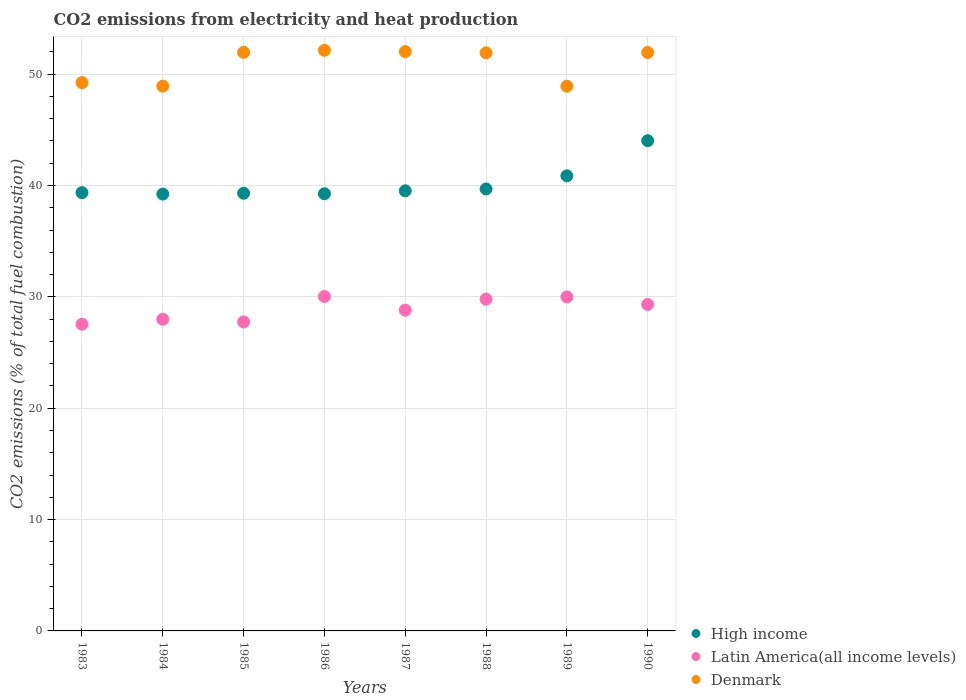Is the number of dotlines equal to the number of legend labels?
Offer a very short reply. Yes. What is the amount of CO2 emitted in High income in 1984?
Offer a very short reply. 39.23. Across all years, what is the maximum amount of CO2 emitted in High income?
Your answer should be very brief. 44.02. Across all years, what is the minimum amount of CO2 emitted in Denmark?
Offer a very short reply. 48.92. In which year was the amount of CO2 emitted in Denmark maximum?
Keep it short and to the point. 1986. In which year was the amount of CO2 emitted in Latin America(all income levels) minimum?
Provide a succinct answer. 1983. What is the total amount of CO2 emitted in Latin America(all income levels) in the graph?
Provide a short and direct response. 231.22. What is the difference between the amount of CO2 emitted in Latin America(all income levels) in 1986 and that in 1988?
Your answer should be very brief. 0.24. What is the difference between the amount of CO2 emitted in Latin America(all income levels) in 1984 and the amount of CO2 emitted in Denmark in 1987?
Ensure brevity in your answer.  -24.03. What is the average amount of CO2 emitted in High income per year?
Offer a terse response. 40.16. In the year 1987, what is the difference between the amount of CO2 emitted in Latin America(all income levels) and amount of CO2 emitted in High income?
Provide a succinct answer. -10.72. In how many years, is the amount of CO2 emitted in Latin America(all income levels) greater than 48 %?
Give a very brief answer. 0. What is the ratio of the amount of CO2 emitted in Denmark in 1983 to that in 1988?
Give a very brief answer. 0.95. Is the amount of CO2 emitted in Denmark in 1988 less than that in 1989?
Make the answer very short. No. Is the difference between the amount of CO2 emitted in Latin America(all income levels) in 1984 and 1990 greater than the difference between the amount of CO2 emitted in High income in 1984 and 1990?
Your answer should be very brief. Yes. What is the difference between the highest and the second highest amount of CO2 emitted in Denmark?
Keep it short and to the point. 0.12. What is the difference between the highest and the lowest amount of CO2 emitted in High income?
Your response must be concise. 4.79. Is the sum of the amount of CO2 emitted in High income in 1985 and 1988 greater than the maximum amount of CO2 emitted in Latin America(all income levels) across all years?
Provide a short and direct response. Yes. Does the amount of CO2 emitted in Denmark monotonically increase over the years?
Offer a terse response. No. Is the amount of CO2 emitted in Latin America(all income levels) strictly greater than the amount of CO2 emitted in Denmark over the years?
Keep it short and to the point. No. How many legend labels are there?
Provide a succinct answer. 3. How are the legend labels stacked?
Offer a terse response. Vertical. What is the title of the graph?
Provide a succinct answer. CO2 emissions from electricity and heat production. What is the label or title of the X-axis?
Your response must be concise. Years. What is the label or title of the Y-axis?
Give a very brief answer. CO2 emissions (% of total fuel combustion). What is the CO2 emissions (% of total fuel combustion) of High income in 1983?
Your answer should be compact. 39.36. What is the CO2 emissions (% of total fuel combustion) in Latin America(all income levels) in 1983?
Keep it short and to the point. 27.54. What is the CO2 emissions (% of total fuel combustion) in Denmark in 1983?
Give a very brief answer. 49.24. What is the CO2 emissions (% of total fuel combustion) in High income in 1984?
Ensure brevity in your answer.  39.23. What is the CO2 emissions (% of total fuel combustion) of Latin America(all income levels) in 1984?
Keep it short and to the point. 27.99. What is the CO2 emissions (% of total fuel combustion) in Denmark in 1984?
Ensure brevity in your answer.  48.92. What is the CO2 emissions (% of total fuel combustion) of High income in 1985?
Provide a short and direct response. 39.31. What is the CO2 emissions (% of total fuel combustion) in Latin America(all income levels) in 1985?
Your answer should be very brief. 27.75. What is the CO2 emissions (% of total fuel combustion) of Denmark in 1985?
Your response must be concise. 51.96. What is the CO2 emissions (% of total fuel combustion) of High income in 1986?
Offer a very short reply. 39.26. What is the CO2 emissions (% of total fuel combustion) in Latin America(all income levels) in 1986?
Keep it short and to the point. 30.03. What is the CO2 emissions (% of total fuel combustion) of Denmark in 1986?
Your answer should be compact. 52.14. What is the CO2 emissions (% of total fuel combustion) of High income in 1987?
Your answer should be very brief. 39.52. What is the CO2 emissions (% of total fuel combustion) in Latin America(all income levels) in 1987?
Offer a very short reply. 28.8. What is the CO2 emissions (% of total fuel combustion) of Denmark in 1987?
Keep it short and to the point. 52.02. What is the CO2 emissions (% of total fuel combustion) of High income in 1988?
Ensure brevity in your answer.  39.69. What is the CO2 emissions (% of total fuel combustion) of Latin America(all income levels) in 1988?
Ensure brevity in your answer.  29.79. What is the CO2 emissions (% of total fuel combustion) in Denmark in 1988?
Offer a terse response. 51.92. What is the CO2 emissions (% of total fuel combustion) in High income in 1989?
Make the answer very short. 40.87. What is the CO2 emissions (% of total fuel combustion) in Latin America(all income levels) in 1989?
Offer a very short reply. 29.99. What is the CO2 emissions (% of total fuel combustion) of Denmark in 1989?
Offer a very short reply. 48.92. What is the CO2 emissions (% of total fuel combustion) in High income in 1990?
Offer a terse response. 44.02. What is the CO2 emissions (% of total fuel combustion) of Latin America(all income levels) in 1990?
Ensure brevity in your answer.  29.32. What is the CO2 emissions (% of total fuel combustion) in Denmark in 1990?
Ensure brevity in your answer.  51.95. Across all years, what is the maximum CO2 emissions (% of total fuel combustion) in High income?
Your answer should be compact. 44.02. Across all years, what is the maximum CO2 emissions (% of total fuel combustion) of Latin America(all income levels)?
Your answer should be very brief. 30.03. Across all years, what is the maximum CO2 emissions (% of total fuel combustion) of Denmark?
Your answer should be compact. 52.14. Across all years, what is the minimum CO2 emissions (% of total fuel combustion) of High income?
Provide a succinct answer. 39.23. Across all years, what is the minimum CO2 emissions (% of total fuel combustion) in Latin America(all income levels)?
Make the answer very short. 27.54. Across all years, what is the minimum CO2 emissions (% of total fuel combustion) in Denmark?
Offer a terse response. 48.92. What is the total CO2 emissions (% of total fuel combustion) of High income in the graph?
Offer a very short reply. 321.25. What is the total CO2 emissions (% of total fuel combustion) in Latin America(all income levels) in the graph?
Provide a succinct answer. 231.22. What is the total CO2 emissions (% of total fuel combustion) in Denmark in the graph?
Offer a very short reply. 407.07. What is the difference between the CO2 emissions (% of total fuel combustion) of High income in 1983 and that in 1984?
Make the answer very short. 0.13. What is the difference between the CO2 emissions (% of total fuel combustion) of Latin America(all income levels) in 1983 and that in 1984?
Ensure brevity in your answer.  -0.45. What is the difference between the CO2 emissions (% of total fuel combustion) of Denmark in 1983 and that in 1984?
Make the answer very short. 0.32. What is the difference between the CO2 emissions (% of total fuel combustion) in High income in 1983 and that in 1985?
Offer a terse response. 0.05. What is the difference between the CO2 emissions (% of total fuel combustion) of Latin America(all income levels) in 1983 and that in 1985?
Give a very brief answer. -0.21. What is the difference between the CO2 emissions (% of total fuel combustion) in Denmark in 1983 and that in 1985?
Ensure brevity in your answer.  -2.72. What is the difference between the CO2 emissions (% of total fuel combustion) of High income in 1983 and that in 1986?
Your answer should be compact. 0.1. What is the difference between the CO2 emissions (% of total fuel combustion) of Latin America(all income levels) in 1983 and that in 1986?
Offer a very short reply. -2.49. What is the difference between the CO2 emissions (% of total fuel combustion) in Denmark in 1983 and that in 1986?
Your response must be concise. -2.9. What is the difference between the CO2 emissions (% of total fuel combustion) of High income in 1983 and that in 1987?
Make the answer very short. -0.17. What is the difference between the CO2 emissions (% of total fuel combustion) in Latin America(all income levels) in 1983 and that in 1987?
Provide a short and direct response. -1.26. What is the difference between the CO2 emissions (% of total fuel combustion) of Denmark in 1983 and that in 1987?
Provide a succinct answer. -2.78. What is the difference between the CO2 emissions (% of total fuel combustion) in High income in 1983 and that in 1988?
Ensure brevity in your answer.  -0.33. What is the difference between the CO2 emissions (% of total fuel combustion) of Latin America(all income levels) in 1983 and that in 1988?
Your response must be concise. -2.25. What is the difference between the CO2 emissions (% of total fuel combustion) in Denmark in 1983 and that in 1988?
Your answer should be compact. -2.68. What is the difference between the CO2 emissions (% of total fuel combustion) of High income in 1983 and that in 1989?
Provide a short and direct response. -1.51. What is the difference between the CO2 emissions (% of total fuel combustion) in Latin America(all income levels) in 1983 and that in 1989?
Your response must be concise. -2.45. What is the difference between the CO2 emissions (% of total fuel combustion) of Denmark in 1983 and that in 1989?
Ensure brevity in your answer.  0.32. What is the difference between the CO2 emissions (% of total fuel combustion) of High income in 1983 and that in 1990?
Your response must be concise. -4.67. What is the difference between the CO2 emissions (% of total fuel combustion) in Latin America(all income levels) in 1983 and that in 1990?
Your response must be concise. -1.78. What is the difference between the CO2 emissions (% of total fuel combustion) of Denmark in 1983 and that in 1990?
Make the answer very short. -2.71. What is the difference between the CO2 emissions (% of total fuel combustion) in High income in 1984 and that in 1985?
Provide a succinct answer. -0.08. What is the difference between the CO2 emissions (% of total fuel combustion) of Latin America(all income levels) in 1984 and that in 1985?
Your answer should be compact. 0.24. What is the difference between the CO2 emissions (% of total fuel combustion) in Denmark in 1984 and that in 1985?
Offer a terse response. -3.04. What is the difference between the CO2 emissions (% of total fuel combustion) of High income in 1984 and that in 1986?
Make the answer very short. -0.03. What is the difference between the CO2 emissions (% of total fuel combustion) of Latin America(all income levels) in 1984 and that in 1986?
Give a very brief answer. -2.04. What is the difference between the CO2 emissions (% of total fuel combustion) in Denmark in 1984 and that in 1986?
Give a very brief answer. -3.22. What is the difference between the CO2 emissions (% of total fuel combustion) of High income in 1984 and that in 1987?
Your answer should be very brief. -0.29. What is the difference between the CO2 emissions (% of total fuel combustion) in Latin America(all income levels) in 1984 and that in 1987?
Offer a terse response. -0.81. What is the difference between the CO2 emissions (% of total fuel combustion) in Denmark in 1984 and that in 1987?
Offer a terse response. -3.1. What is the difference between the CO2 emissions (% of total fuel combustion) in High income in 1984 and that in 1988?
Your response must be concise. -0.46. What is the difference between the CO2 emissions (% of total fuel combustion) in Latin America(all income levels) in 1984 and that in 1988?
Make the answer very short. -1.8. What is the difference between the CO2 emissions (% of total fuel combustion) in Denmark in 1984 and that in 1988?
Your answer should be compact. -3. What is the difference between the CO2 emissions (% of total fuel combustion) in High income in 1984 and that in 1989?
Offer a very short reply. -1.64. What is the difference between the CO2 emissions (% of total fuel combustion) of Latin America(all income levels) in 1984 and that in 1989?
Ensure brevity in your answer.  -2. What is the difference between the CO2 emissions (% of total fuel combustion) in Denmark in 1984 and that in 1989?
Offer a terse response. 0.01. What is the difference between the CO2 emissions (% of total fuel combustion) of High income in 1984 and that in 1990?
Your response must be concise. -4.79. What is the difference between the CO2 emissions (% of total fuel combustion) of Latin America(all income levels) in 1984 and that in 1990?
Offer a terse response. -1.33. What is the difference between the CO2 emissions (% of total fuel combustion) in Denmark in 1984 and that in 1990?
Your answer should be very brief. -3.02. What is the difference between the CO2 emissions (% of total fuel combustion) of High income in 1985 and that in 1986?
Your answer should be very brief. 0.05. What is the difference between the CO2 emissions (% of total fuel combustion) in Latin America(all income levels) in 1985 and that in 1986?
Give a very brief answer. -2.29. What is the difference between the CO2 emissions (% of total fuel combustion) of Denmark in 1985 and that in 1986?
Ensure brevity in your answer.  -0.19. What is the difference between the CO2 emissions (% of total fuel combustion) in High income in 1985 and that in 1987?
Provide a short and direct response. -0.22. What is the difference between the CO2 emissions (% of total fuel combustion) of Latin America(all income levels) in 1985 and that in 1987?
Ensure brevity in your answer.  -1.05. What is the difference between the CO2 emissions (% of total fuel combustion) in Denmark in 1985 and that in 1987?
Make the answer very short. -0.07. What is the difference between the CO2 emissions (% of total fuel combustion) in High income in 1985 and that in 1988?
Your answer should be very brief. -0.38. What is the difference between the CO2 emissions (% of total fuel combustion) of Latin America(all income levels) in 1985 and that in 1988?
Offer a very short reply. -2.05. What is the difference between the CO2 emissions (% of total fuel combustion) of Denmark in 1985 and that in 1988?
Keep it short and to the point. 0.04. What is the difference between the CO2 emissions (% of total fuel combustion) in High income in 1985 and that in 1989?
Make the answer very short. -1.56. What is the difference between the CO2 emissions (% of total fuel combustion) in Latin America(all income levels) in 1985 and that in 1989?
Give a very brief answer. -2.24. What is the difference between the CO2 emissions (% of total fuel combustion) of Denmark in 1985 and that in 1989?
Your answer should be very brief. 3.04. What is the difference between the CO2 emissions (% of total fuel combustion) in High income in 1985 and that in 1990?
Provide a short and direct response. -4.72. What is the difference between the CO2 emissions (% of total fuel combustion) of Latin America(all income levels) in 1985 and that in 1990?
Give a very brief answer. -1.57. What is the difference between the CO2 emissions (% of total fuel combustion) of Denmark in 1985 and that in 1990?
Make the answer very short. 0.01. What is the difference between the CO2 emissions (% of total fuel combustion) in High income in 1986 and that in 1987?
Provide a short and direct response. -0.27. What is the difference between the CO2 emissions (% of total fuel combustion) of Latin America(all income levels) in 1986 and that in 1987?
Provide a succinct answer. 1.23. What is the difference between the CO2 emissions (% of total fuel combustion) of Denmark in 1986 and that in 1987?
Your response must be concise. 0.12. What is the difference between the CO2 emissions (% of total fuel combustion) of High income in 1986 and that in 1988?
Your answer should be compact. -0.43. What is the difference between the CO2 emissions (% of total fuel combustion) of Latin America(all income levels) in 1986 and that in 1988?
Your answer should be very brief. 0.24. What is the difference between the CO2 emissions (% of total fuel combustion) in Denmark in 1986 and that in 1988?
Provide a short and direct response. 0.23. What is the difference between the CO2 emissions (% of total fuel combustion) in High income in 1986 and that in 1989?
Make the answer very short. -1.61. What is the difference between the CO2 emissions (% of total fuel combustion) in Latin America(all income levels) in 1986 and that in 1989?
Your answer should be very brief. 0.04. What is the difference between the CO2 emissions (% of total fuel combustion) in Denmark in 1986 and that in 1989?
Give a very brief answer. 3.23. What is the difference between the CO2 emissions (% of total fuel combustion) in High income in 1986 and that in 1990?
Your response must be concise. -4.77. What is the difference between the CO2 emissions (% of total fuel combustion) in Latin America(all income levels) in 1986 and that in 1990?
Give a very brief answer. 0.72. What is the difference between the CO2 emissions (% of total fuel combustion) in Denmark in 1986 and that in 1990?
Your answer should be compact. 0.2. What is the difference between the CO2 emissions (% of total fuel combustion) in High income in 1987 and that in 1988?
Provide a short and direct response. -0.16. What is the difference between the CO2 emissions (% of total fuel combustion) of Latin America(all income levels) in 1987 and that in 1988?
Make the answer very short. -0.99. What is the difference between the CO2 emissions (% of total fuel combustion) in Denmark in 1987 and that in 1988?
Make the answer very short. 0.11. What is the difference between the CO2 emissions (% of total fuel combustion) of High income in 1987 and that in 1989?
Provide a short and direct response. -1.34. What is the difference between the CO2 emissions (% of total fuel combustion) of Latin America(all income levels) in 1987 and that in 1989?
Ensure brevity in your answer.  -1.19. What is the difference between the CO2 emissions (% of total fuel combustion) in Denmark in 1987 and that in 1989?
Offer a terse response. 3.11. What is the difference between the CO2 emissions (% of total fuel combustion) in High income in 1987 and that in 1990?
Provide a short and direct response. -4.5. What is the difference between the CO2 emissions (% of total fuel combustion) in Latin America(all income levels) in 1987 and that in 1990?
Give a very brief answer. -0.51. What is the difference between the CO2 emissions (% of total fuel combustion) in Denmark in 1987 and that in 1990?
Provide a short and direct response. 0.08. What is the difference between the CO2 emissions (% of total fuel combustion) in High income in 1988 and that in 1989?
Provide a succinct answer. -1.18. What is the difference between the CO2 emissions (% of total fuel combustion) of Latin America(all income levels) in 1988 and that in 1989?
Your answer should be very brief. -0.2. What is the difference between the CO2 emissions (% of total fuel combustion) of Denmark in 1988 and that in 1989?
Your answer should be compact. 3. What is the difference between the CO2 emissions (% of total fuel combustion) in High income in 1988 and that in 1990?
Make the answer very short. -4.34. What is the difference between the CO2 emissions (% of total fuel combustion) in Latin America(all income levels) in 1988 and that in 1990?
Your answer should be very brief. 0.48. What is the difference between the CO2 emissions (% of total fuel combustion) in Denmark in 1988 and that in 1990?
Your answer should be very brief. -0.03. What is the difference between the CO2 emissions (% of total fuel combustion) in High income in 1989 and that in 1990?
Make the answer very short. -3.16. What is the difference between the CO2 emissions (% of total fuel combustion) in Latin America(all income levels) in 1989 and that in 1990?
Offer a very short reply. 0.67. What is the difference between the CO2 emissions (% of total fuel combustion) of Denmark in 1989 and that in 1990?
Give a very brief answer. -3.03. What is the difference between the CO2 emissions (% of total fuel combustion) in High income in 1983 and the CO2 emissions (% of total fuel combustion) in Latin America(all income levels) in 1984?
Provide a succinct answer. 11.37. What is the difference between the CO2 emissions (% of total fuel combustion) in High income in 1983 and the CO2 emissions (% of total fuel combustion) in Denmark in 1984?
Your answer should be compact. -9.56. What is the difference between the CO2 emissions (% of total fuel combustion) in Latin America(all income levels) in 1983 and the CO2 emissions (% of total fuel combustion) in Denmark in 1984?
Your answer should be compact. -21.38. What is the difference between the CO2 emissions (% of total fuel combustion) of High income in 1983 and the CO2 emissions (% of total fuel combustion) of Latin America(all income levels) in 1985?
Offer a terse response. 11.61. What is the difference between the CO2 emissions (% of total fuel combustion) of High income in 1983 and the CO2 emissions (% of total fuel combustion) of Denmark in 1985?
Your response must be concise. -12.6. What is the difference between the CO2 emissions (% of total fuel combustion) of Latin America(all income levels) in 1983 and the CO2 emissions (% of total fuel combustion) of Denmark in 1985?
Provide a succinct answer. -24.42. What is the difference between the CO2 emissions (% of total fuel combustion) in High income in 1983 and the CO2 emissions (% of total fuel combustion) in Latin America(all income levels) in 1986?
Offer a terse response. 9.32. What is the difference between the CO2 emissions (% of total fuel combustion) in High income in 1983 and the CO2 emissions (% of total fuel combustion) in Denmark in 1986?
Provide a succinct answer. -12.79. What is the difference between the CO2 emissions (% of total fuel combustion) of Latin America(all income levels) in 1983 and the CO2 emissions (% of total fuel combustion) of Denmark in 1986?
Ensure brevity in your answer.  -24.6. What is the difference between the CO2 emissions (% of total fuel combustion) in High income in 1983 and the CO2 emissions (% of total fuel combustion) in Latin America(all income levels) in 1987?
Offer a very short reply. 10.55. What is the difference between the CO2 emissions (% of total fuel combustion) in High income in 1983 and the CO2 emissions (% of total fuel combustion) in Denmark in 1987?
Provide a short and direct response. -12.67. What is the difference between the CO2 emissions (% of total fuel combustion) of Latin America(all income levels) in 1983 and the CO2 emissions (% of total fuel combustion) of Denmark in 1987?
Make the answer very short. -24.48. What is the difference between the CO2 emissions (% of total fuel combustion) of High income in 1983 and the CO2 emissions (% of total fuel combustion) of Latin America(all income levels) in 1988?
Offer a very short reply. 9.56. What is the difference between the CO2 emissions (% of total fuel combustion) of High income in 1983 and the CO2 emissions (% of total fuel combustion) of Denmark in 1988?
Keep it short and to the point. -12.56. What is the difference between the CO2 emissions (% of total fuel combustion) in Latin America(all income levels) in 1983 and the CO2 emissions (% of total fuel combustion) in Denmark in 1988?
Offer a terse response. -24.38. What is the difference between the CO2 emissions (% of total fuel combustion) in High income in 1983 and the CO2 emissions (% of total fuel combustion) in Latin America(all income levels) in 1989?
Offer a terse response. 9.37. What is the difference between the CO2 emissions (% of total fuel combustion) of High income in 1983 and the CO2 emissions (% of total fuel combustion) of Denmark in 1989?
Make the answer very short. -9.56. What is the difference between the CO2 emissions (% of total fuel combustion) in Latin America(all income levels) in 1983 and the CO2 emissions (% of total fuel combustion) in Denmark in 1989?
Offer a very short reply. -21.38. What is the difference between the CO2 emissions (% of total fuel combustion) in High income in 1983 and the CO2 emissions (% of total fuel combustion) in Latin America(all income levels) in 1990?
Your response must be concise. 10.04. What is the difference between the CO2 emissions (% of total fuel combustion) in High income in 1983 and the CO2 emissions (% of total fuel combustion) in Denmark in 1990?
Provide a succinct answer. -12.59. What is the difference between the CO2 emissions (% of total fuel combustion) in Latin America(all income levels) in 1983 and the CO2 emissions (% of total fuel combustion) in Denmark in 1990?
Provide a succinct answer. -24.41. What is the difference between the CO2 emissions (% of total fuel combustion) in High income in 1984 and the CO2 emissions (% of total fuel combustion) in Latin America(all income levels) in 1985?
Offer a very short reply. 11.48. What is the difference between the CO2 emissions (% of total fuel combustion) in High income in 1984 and the CO2 emissions (% of total fuel combustion) in Denmark in 1985?
Ensure brevity in your answer.  -12.73. What is the difference between the CO2 emissions (% of total fuel combustion) of Latin America(all income levels) in 1984 and the CO2 emissions (% of total fuel combustion) of Denmark in 1985?
Offer a very short reply. -23.97. What is the difference between the CO2 emissions (% of total fuel combustion) in High income in 1984 and the CO2 emissions (% of total fuel combustion) in Latin America(all income levels) in 1986?
Your answer should be very brief. 9.19. What is the difference between the CO2 emissions (% of total fuel combustion) of High income in 1984 and the CO2 emissions (% of total fuel combustion) of Denmark in 1986?
Ensure brevity in your answer.  -12.91. What is the difference between the CO2 emissions (% of total fuel combustion) in Latin America(all income levels) in 1984 and the CO2 emissions (% of total fuel combustion) in Denmark in 1986?
Offer a very short reply. -24.15. What is the difference between the CO2 emissions (% of total fuel combustion) of High income in 1984 and the CO2 emissions (% of total fuel combustion) of Latin America(all income levels) in 1987?
Ensure brevity in your answer.  10.43. What is the difference between the CO2 emissions (% of total fuel combustion) of High income in 1984 and the CO2 emissions (% of total fuel combustion) of Denmark in 1987?
Offer a terse response. -12.79. What is the difference between the CO2 emissions (% of total fuel combustion) of Latin America(all income levels) in 1984 and the CO2 emissions (% of total fuel combustion) of Denmark in 1987?
Give a very brief answer. -24.03. What is the difference between the CO2 emissions (% of total fuel combustion) of High income in 1984 and the CO2 emissions (% of total fuel combustion) of Latin America(all income levels) in 1988?
Your answer should be very brief. 9.44. What is the difference between the CO2 emissions (% of total fuel combustion) of High income in 1984 and the CO2 emissions (% of total fuel combustion) of Denmark in 1988?
Offer a very short reply. -12.69. What is the difference between the CO2 emissions (% of total fuel combustion) in Latin America(all income levels) in 1984 and the CO2 emissions (% of total fuel combustion) in Denmark in 1988?
Give a very brief answer. -23.93. What is the difference between the CO2 emissions (% of total fuel combustion) in High income in 1984 and the CO2 emissions (% of total fuel combustion) in Latin America(all income levels) in 1989?
Keep it short and to the point. 9.24. What is the difference between the CO2 emissions (% of total fuel combustion) in High income in 1984 and the CO2 emissions (% of total fuel combustion) in Denmark in 1989?
Keep it short and to the point. -9.69. What is the difference between the CO2 emissions (% of total fuel combustion) in Latin America(all income levels) in 1984 and the CO2 emissions (% of total fuel combustion) in Denmark in 1989?
Ensure brevity in your answer.  -20.93. What is the difference between the CO2 emissions (% of total fuel combustion) of High income in 1984 and the CO2 emissions (% of total fuel combustion) of Latin America(all income levels) in 1990?
Offer a very short reply. 9.91. What is the difference between the CO2 emissions (% of total fuel combustion) of High income in 1984 and the CO2 emissions (% of total fuel combustion) of Denmark in 1990?
Offer a terse response. -12.72. What is the difference between the CO2 emissions (% of total fuel combustion) in Latin America(all income levels) in 1984 and the CO2 emissions (% of total fuel combustion) in Denmark in 1990?
Offer a terse response. -23.96. What is the difference between the CO2 emissions (% of total fuel combustion) of High income in 1985 and the CO2 emissions (% of total fuel combustion) of Latin America(all income levels) in 1986?
Keep it short and to the point. 9.27. What is the difference between the CO2 emissions (% of total fuel combustion) of High income in 1985 and the CO2 emissions (% of total fuel combustion) of Denmark in 1986?
Offer a very short reply. -12.84. What is the difference between the CO2 emissions (% of total fuel combustion) in Latin America(all income levels) in 1985 and the CO2 emissions (% of total fuel combustion) in Denmark in 1986?
Offer a terse response. -24.39. What is the difference between the CO2 emissions (% of total fuel combustion) in High income in 1985 and the CO2 emissions (% of total fuel combustion) in Latin America(all income levels) in 1987?
Make the answer very short. 10.5. What is the difference between the CO2 emissions (% of total fuel combustion) in High income in 1985 and the CO2 emissions (% of total fuel combustion) in Denmark in 1987?
Give a very brief answer. -12.72. What is the difference between the CO2 emissions (% of total fuel combustion) in Latin America(all income levels) in 1985 and the CO2 emissions (% of total fuel combustion) in Denmark in 1987?
Give a very brief answer. -24.28. What is the difference between the CO2 emissions (% of total fuel combustion) of High income in 1985 and the CO2 emissions (% of total fuel combustion) of Latin America(all income levels) in 1988?
Your response must be concise. 9.51. What is the difference between the CO2 emissions (% of total fuel combustion) of High income in 1985 and the CO2 emissions (% of total fuel combustion) of Denmark in 1988?
Provide a succinct answer. -12.61. What is the difference between the CO2 emissions (% of total fuel combustion) in Latin America(all income levels) in 1985 and the CO2 emissions (% of total fuel combustion) in Denmark in 1988?
Offer a very short reply. -24.17. What is the difference between the CO2 emissions (% of total fuel combustion) in High income in 1985 and the CO2 emissions (% of total fuel combustion) in Latin America(all income levels) in 1989?
Your answer should be compact. 9.31. What is the difference between the CO2 emissions (% of total fuel combustion) in High income in 1985 and the CO2 emissions (% of total fuel combustion) in Denmark in 1989?
Provide a short and direct response. -9.61. What is the difference between the CO2 emissions (% of total fuel combustion) of Latin America(all income levels) in 1985 and the CO2 emissions (% of total fuel combustion) of Denmark in 1989?
Offer a very short reply. -21.17. What is the difference between the CO2 emissions (% of total fuel combustion) of High income in 1985 and the CO2 emissions (% of total fuel combustion) of Latin America(all income levels) in 1990?
Keep it short and to the point. 9.99. What is the difference between the CO2 emissions (% of total fuel combustion) of High income in 1985 and the CO2 emissions (% of total fuel combustion) of Denmark in 1990?
Offer a very short reply. -12.64. What is the difference between the CO2 emissions (% of total fuel combustion) in Latin America(all income levels) in 1985 and the CO2 emissions (% of total fuel combustion) in Denmark in 1990?
Your answer should be compact. -24.2. What is the difference between the CO2 emissions (% of total fuel combustion) of High income in 1986 and the CO2 emissions (% of total fuel combustion) of Latin America(all income levels) in 1987?
Your answer should be compact. 10.45. What is the difference between the CO2 emissions (% of total fuel combustion) in High income in 1986 and the CO2 emissions (% of total fuel combustion) in Denmark in 1987?
Ensure brevity in your answer.  -12.77. What is the difference between the CO2 emissions (% of total fuel combustion) of Latin America(all income levels) in 1986 and the CO2 emissions (% of total fuel combustion) of Denmark in 1987?
Make the answer very short. -21.99. What is the difference between the CO2 emissions (% of total fuel combustion) in High income in 1986 and the CO2 emissions (% of total fuel combustion) in Latin America(all income levels) in 1988?
Offer a very short reply. 9.46. What is the difference between the CO2 emissions (% of total fuel combustion) of High income in 1986 and the CO2 emissions (% of total fuel combustion) of Denmark in 1988?
Ensure brevity in your answer.  -12.66. What is the difference between the CO2 emissions (% of total fuel combustion) of Latin America(all income levels) in 1986 and the CO2 emissions (% of total fuel combustion) of Denmark in 1988?
Ensure brevity in your answer.  -21.88. What is the difference between the CO2 emissions (% of total fuel combustion) in High income in 1986 and the CO2 emissions (% of total fuel combustion) in Latin America(all income levels) in 1989?
Your answer should be compact. 9.27. What is the difference between the CO2 emissions (% of total fuel combustion) in High income in 1986 and the CO2 emissions (% of total fuel combustion) in Denmark in 1989?
Ensure brevity in your answer.  -9.66. What is the difference between the CO2 emissions (% of total fuel combustion) of Latin America(all income levels) in 1986 and the CO2 emissions (% of total fuel combustion) of Denmark in 1989?
Give a very brief answer. -18.88. What is the difference between the CO2 emissions (% of total fuel combustion) of High income in 1986 and the CO2 emissions (% of total fuel combustion) of Latin America(all income levels) in 1990?
Keep it short and to the point. 9.94. What is the difference between the CO2 emissions (% of total fuel combustion) of High income in 1986 and the CO2 emissions (% of total fuel combustion) of Denmark in 1990?
Provide a succinct answer. -12.69. What is the difference between the CO2 emissions (% of total fuel combustion) of Latin America(all income levels) in 1986 and the CO2 emissions (% of total fuel combustion) of Denmark in 1990?
Your answer should be compact. -21.91. What is the difference between the CO2 emissions (% of total fuel combustion) in High income in 1987 and the CO2 emissions (% of total fuel combustion) in Latin America(all income levels) in 1988?
Give a very brief answer. 9.73. What is the difference between the CO2 emissions (% of total fuel combustion) of High income in 1987 and the CO2 emissions (% of total fuel combustion) of Denmark in 1988?
Your answer should be very brief. -12.39. What is the difference between the CO2 emissions (% of total fuel combustion) in Latin America(all income levels) in 1987 and the CO2 emissions (% of total fuel combustion) in Denmark in 1988?
Offer a very short reply. -23.12. What is the difference between the CO2 emissions (% of total fuel combustion) in High income in 1987 and the CO2 emissions (% of total fuel combustion) in Latin America(all income levels) in 1989?
Offer a terse response. 9.53. What is the difference between the CO2 emissions (% of total fuel combustion) in High income in 1987 and the CO2 emissions (% of total fuel combustion) in Denmark in 1989?
Your answer should be very brief. -9.39. What is the difference between the CO2 emissions (% of total fuel combustion) in Latin America(all income levels) in 1987 and the CO2 emissions (% of total fuel combustion) in Denmark in 1989?
Ensure brevity in your answer.  -20.11. What is the difference between the CO2 emissions (% of total fuel combustion) of High income in 1987 and the CO2 emissions (% of total fuel combustion) of Latin America(all income levels) in 1990?
Your response must be concise. 10.21. What is the difference between the CO2 emissions (% of total fuel combustion) of High income in 1987 and the CO2 emissions (% of total fuel combustion) of Denmark in 1990?
Provide a succinct answer. -12.42. What is the difference between the CO2 emissions (% of total fuel combustion) of Latin America(all income levels) in 1987 and the CO2 emissions (% of total fuel combustion) of Denmark in 1990?
Keep it short and to the point. -23.14. What is the difference between the CO2 emissions (% of total fuel combustion) of High income in 1988 and the CO2 emissions (% of total fuel combustion) of Latin America(all income levels) in 1989?
Offer a very short reply. 9.7. What is the difference between the CO2 emissions (% of total fuel combustion) in High income in 1988 and the CO2 emissions (% of total fuel combustion) in Denmark in 1989?
Give a very brief answer. -9.23. What is the difference between the CO2 emissions (% of total fuel combustion) of Latin America(all income levels) in 1988 and the CO2 emissions (% of total fuel combustion) of Denmark in 1989?
Your answer should be compact. -19.12. What is the difference between the CO2 emissions (% of total fuel combustion) in High income in 1988 and the CO2 emissions (% of total fuel combustion) in Latin America(all income levels) in 1990?
Give a very brief answer. 10.37. What is the difference between the CO2 emissions (% of total fuel combustion) in High income in 1988 and the CO2 emissions (% of total fuel combustion) in Denmark in 1990?
Make the answer very short. -12.26. What is the difference between the CO2 emissions (% of total fuel combustion) in Latin America(all income levels) in 1988 and the CO2 emissions (% of total fuel combustion) in Denmark in 1990?
Your answer should be compact. -22.15. What is the difference between the CO2 emissions (% of total fuel combustion) of High income in 1989 and the CO2 emissions (% of total fuel combustion) of Latin America(all income levels) in 1990?
Provide a short and direct response. 11.55. What is the difference between the CO2 emissions (% of total fuel combustion) in High income in 1989 and the CO2 emissions (% of total fuel combustion) in Denmark in 1990?
Give a very brief answer. -11.08. What is the difference between the CO2 emissions (% of total fuel combustion) in Latin America(all income levels) in 1989 and the CO2 emissions (% of total fuel combustion) in Denmark in 1990?
Provide a short and direct response. -21.95. What is the average CO2 emissions (% of total fuel combustion) of High income per year?
Offer a very short reply. 40.16. What is the average CO2 emissions (% of total fuel combustion) in Latin America(all income levels) per year?
Keep it short and to the point. 28.9. What is the average CO2 emissions (% of total fuel combustion) of Denmark per year?
Your answer should be compact. 50.88. In the year 1983, what is the difference between the CO2 emissions (% of total fuel combustion) of High income and CO2 emissions (% of total fuel combustion) of Latin America(all income levels)?
Keep it short and to the point. 11.82. In the year 1983, what is the difference between the CO2 emissions (% of total fuel combustion) of High income and CO2 emissions (% of total fuel combustion) of Denmark?
Offer a very short reply. -9.88. In the year 1983, what is the difference between the CO2 emissions (% of total fuel combustion) in Latin America(all income levels) and CO2 emissions (% of total fuel combustion) in Denmark?
Make the answer very short. -21.7. In the year 1984, what is the difference between the CO2 emissions (% of total fuel combustion) in High income and CO2 emissions (% of total fuel combustion) in Latin America(all income levels)?
Offer a very short reply. 11.24. In the year 1984, what is the difference between the CO2 emissions (% of total fuel combustion) of High income and CO2 emissions (% of total fuel combustion) of Denmark?
Your response must be concise. -9.69. In the year 1984, what is the difference between the CO2 emissions (% of total fuel combustion) in Latin America(all income levels) and CO2 emissions (% of total fuel combustion) in Denmark?
Provide a succinct answer. -20.93. In the year 1985, what is the difference between the CO2 emissions (% of total fuel combustion) in High income and CO2 emissions (% of total fuel combustion) in Latin America(all income levels)?
Provide a succinct answer. 11.56. In the year 1985, what is the difference between the CO2 emissions (% of total fuel combustion) in High income and CO2 emissions (% of total fuel combustion) in Denmark?
Your response must be concise. -12.65. In the year 1985, what is the difference between the CO2 emissions (% of total fuel combustion) of Latin America(all income levels) and CO2 emissions (% of total fuel combustion) of Denmark?
Ensure brevity in your answer.  -24.21. In the year 1986, what is the difference between the CO2 emissions (% of total fuel combustion) of High income and CO2 emissions (% of total fuel combustion) of Latin America(all income levels)?
Keep it short and to the point. 9.22. In the year 1986, what is the difference between the CO2 emissions (% of total fuel combustion) of High income and CO2 emissions (% of total fuel combustion) of Denmark?
Ensure brevity in your answer.  -12.89. In the year 1986, what is the difference between the CO2 emissions (% of total fuel combustion) in Latin America(all income levels) and CO2 emissions (% of total fuel combustion) in Denmark?
Make the answer very short. -22.11. In the year 1987, what is the difference between the CO2 emissions (% of total fuel combustion) in High income and CO2 emissions (% of total fuel combustion) in Latin America(all income levels)?
Make the answer very short. 10.72. In the year 1987, what is the difference between the CO2 emissions (% of total fuel combustion) of High income and CO2 emissions (% of total fuel combustion) of Denmark?
Your answer should be very brief. -12.5. In the year 1987, what is the difference between the CO2 emissions (% of total fuel combustion) of Latin America(all income levels) and CO2 emissions (% of total fuel combustion) of Denmark?
Offer a terse response. -23.22. In the year 1988, what is the difference between the CO2 emissions (% of total fuel combustion) in High income and CO2 emissions (% of total fuel combustion) in Latin America(all income levels)?
Provide a short and direct response. 9.89. In the year 1988, what is the difference between the CO2 emissions (% of total fuel combustion) in High income and CO2 emissions (% of total fuel combustion) in Denmark?
Your answer should be compact. -12.23. In the year 1988, what is the difference between the CO2 emissions (% of total fuel combustion) of Latin America(all income levels) and CO2 emissions (% of total fuel combustion) of Denmark?
Provide a succinct answer. -22.12. In the year 1989, what is the difference between the CO2 emissions (% of total fuel combustion) of High income and CO2 emissions (% of total fuel combustion) of Latin America(all income levels)?
Make the answer very short. 10.88. In the year 1989, what is the difference between the CO2 emissions (% of total fuel combustion) in High income and CO2 emissions (% of total fuel combustion) in Denmark?
Make the answer very short. -8.05. In the year 1989, what is the difference between the CO2 emissions (% of total fuel combustion) of Latin America(all income levels) and CO2 emissions (% of total fuel combustion) of Denmark?
Provide a succinct answer. -18.92. In the year 1990, what is the difference between the CO2 emissions (% of total fuel combustion) in High income and CO2 emissions (% of total fuel combustion) in Latin America(all income levels)?
Your response must be concise. 14.71. In the year 1990, what is the difference between the CO2 emissions (% of total fuel combustion) in High income and CO2 emissions (% of total fuel combustion) in Denmark?
Provide a succinct answer. -7.92. In the year 1990, what is the difference between the CO2 emissions (% of total fuel combustion) of Latin America(all income levels) and CO2 emissions (% of total fuel combustion) of Denmark?
Make the answer very short. -22.63. What is the ratio of the CO2 emissions (% of total fuel combustion) of Latin America(all income levels) in 1983 to that in 1984?
Offer a very short reply. 0.98. What is the ratio of the CO2 emissions (% of total fuel combustion) in Denmark in 1983 to that in 1984?
Keep it short and to the point. 1.01. What is the ratio of the CO2 emissions (% of total fuel combustion) of High income in 1983 to that in 1985?
Provide a succinct answer. 1. What is the ratio of the CO2 emissions (% of total fuel combustion) in Latin America(all income levels) in 1983 to that in 1985?
Provide a short and direct response. 0.99. What is the ratio of the CO2 emissions (% of total fuel combustion) in Denmark in 1983 to that in 1985?
Your answer should be very brief. 0.95. What is the ratio of the CO2 emissions (% of total fuel combustion) in High income in 1983 to that in 1986?
Provide a short and direct response. 1. What is the ratio of the CO2 emissions (% of total fuel combustion) of Latin America(all income levels) in 1983 to that in 1986?
Provide a short and direct response. 0.92. What is the ratio of the CO2 emissions (% of total fuel combustion) in Denmark in 1983 to that in 1986?
Offer a very short reply. 0.94. What is the ratio of the CO2 emissions (% of total fuel combustion) of Latin America(all income levels) in 1983 to that in 1987?
Ensure brevity in your answer.  0.96. What is the ratio of the CO2 emissions (% of total fuel combustion) of Denmark in 1983 to that in 1987?
Your answer should be compact. 0.95. What is the ratio of the CO2 emissions (% of total fuel combustion) in High income in 1983 to that in 1988?
Provide a short and direct response. 0.99. What is the ratio of the CO2 emissions (% of total fuel combustion) in Latin America(all income levels) in 1983 to that in 1988?
Your answer should be very brief. 0.92. What is the ratio of the CO2 emissions (% of total fuel combustion) in Denmark in 1983 to that in 1988?
Provide a succinct answer. 0.95. What is the ratio of the CO2 emissions (% of total fuel combustion) of High income in 1983 to that in 1989?
Offer a terse response. 0.96. What is the ratio of the CO2 emissions (% of total fuel combustion) of Latin America(all income levels) in 1983 to that in 1989?
Make the answer very short. 0.92. What is the ratio of the CO2 emissions (% of total fuel combustion) of Denmark in 1983 to that in 1989?
Offer a very short reply. 1.01. What is the ratio of the CO2 emissions (% of total fuel combustion) in High income in 1983 to that in 1990?
Keep it short and to the point. 0.89. What is the ratio of the CO2 emissions (% of total fuel combustion) in Latin America(all income levels) in 1983 to that in 1990?
Your answer should be compact. 0.94. What is the ratio of the CO2 emissions (% of total fuel combustion) in Denmark in 1983 to that in 1990?
Ensure brevity in your answer.  0.95. What is the ratio of the CO2 emissions (% of total fuel combustion) in High income in 1984 to that in 1985?
Your answer should be compact. 1. What is the ratio of the CO2 emissions (% of total fuel combustion) of Latin America(all income levels) in 1984 to that in 1985?
Give a very brief answer. 1.01. What is the ratio of the CO2 emissions (% of total fuel combustion) in Denmark in 1984 to that in 1985?
Make the answer very short. 0.94. What is the ratio of the CO2 emissions (% of total fuel combustion) of Latin America(all income levels) in 1984 to that in 1986?
Your response must be concise. 0.93. What is the ratio of the CO2 emissions (% of total fuel combustion) in Denmark in 1984 to that in 1986?
Give a very brief answer. 0.94. What is the ratio of the CO2 emissions (% of total fuel combustion) in Latin America(all income levels) in 1984 to that in 1987?
Your answer should be very brief. 0.97. What is the ratio of the CO2 emissions (% of total fuel combustion) of Denmark in 1984 to that in 1987?
Keep it short and to the point. 0.94. What is the ratio of the CO2 emissions (% of total fuel combustion) of High income in 1984 to that in 1988?
Offer a terse response. 0.99. What is the ratio of the CO2 emissions (% of total fuel combustion) in Latin America(all income levels) in 1984 to that in 1988?
Your answer should be very brief. 0.94. What is the ratio of the CO2 emissions (% of total fuel combustion) in Denmark in 1984 to that in 1988?
Offer a terse response. 0.94. What is the ratio of the CO2 emissions (% of total fuel combustion) of High income in 1984 to that in 1989?
Provide a short and direct response. 0.96. What is the ratio of the CO2 emissions (% of total fuel combustion) of Latin America(all income levels) in 1984 to that in 1989?
Your answer should be compact. 0.93. What is the ratio of the CO2 emissions (% of total fuel combustion) in High income in 1984 to that in 1990?
Your response must be concise. 0.89. What is the ratio of the CO2 emissions (% of total fuel combustion) of Latin America(all income levels) in 1984 to that in 1990?
Provide a succinct answer. 0.95. What is the ratio of the CO2 emissions (% of total fuel combustion) in Denmark in 1984 to that in 1990?
Your response must be concise. 0.94. What is the ratio of the CO2 emissions (% of total fuel combustion) in Latin America(all income levels) in 1985 to that in 1986?
Keep it short and to the point. 0.92. What is the ratio of the CO2 emissions (% of total fuel combustion) of High income in 1985 to that in 1987?
Your answer should be very brief. 0.99. What is the ratio of the CO2 emissions (% of total fuel combustion) in Latin America(all income levels) in 1985 to that in 1987?
Your response must be concise. 0.96. What is the ratio of the CO2 emissions (% of total fuel combustion) of Denmark in 1985 to that in 1987?
Your answer should be very brief. 1. What is the ratio of the CO2 emissions (% of total fuel combustion) in Latin America(all income levels) in 1985 to that in 1988?
Your response must be concise. 0.93. What is the ratio of the CO2 emissions (% of total fuel combustion) in High income in 1985 to that in 1989?
Keep it short and to the point. 0.96. What is the ratio of the CO2 emissions (% of total fuel combustion) in Latin America(all income levels) in 1985 to that in 1989?
Ensure brevity in your answer.  0.93. What is the ratio of the CO2 emissions (% of total fuel combustion) of Denmark in 1985 to that in 1989?
Ensure brevity in your answer.  1.06. What is the ratio of the CO2 emissions (% of total fuel combustion) of High income in 1985 to that in 1990?
Offer a very short reply. 0.89. What is the ratio of the CO2 emissions (% of total fuel combustion) in Latin America(all income levels) in 1985 to that in 1990?
Your answer should be compact. 0.95. What is the ratio of the CO2 emissions (% of total fuel combustion) in Denmark in 1985 to that in 1990?
Your answer should be compact. 1. What is the ratio of the CO2 emissions (% of total fuel combustion) in Latin America(all income levels) in 1986 to that in 1987?
Keep it short and to the point. 1.04. What is the ratio of the CO2 emissions (% of total fuel combustion) of Denmark in 1986 to that in 1987?
Offer a very short reply. 1. What is the ratio of the CO2 emissions (% of total fuel combustion) in High income in 1986 to that in 1989?
Keep it short and to the point. 0.96. What is the ratio of the CO2 emissions (% of total fuel combustion) in Denmark in 1986 to that in 1989?
Make the answer very short. 1.07. What is the ratio of the CO2 emissions (% of total fuel combustion) of High income in 1986 to that in 1990?
Your answer should be very brief. 0.89. What is the ratio of the CO2 emissions (% of total fuel combustion) in Latin America(all income levels) in 1986 to that in 1990?
Provide a succinct answer. 1.02. What is the ratio of the CO2 emissions (% of total fuel combustion) in High income in 1987 to that in 1988?
Offer a very short reply. 1. What is the ratio of the CO2 emissions (% of total fuel combustion) of Latin America(all income levels) in 1987 to that in 1988?
Provide a short and direct response. 0.97. What is the ratio of the CO2 emissions (% of total fuel combustion) of High income in 1987 to that in 1989?
Offer a terse response. 0.97. What is the ratio of the CO2 emissions (% of total fuel combustion) in Latin America(all income levels) in 1987 to that in 1989?
Your answer should be very brief. 0.96. What is the ratio of the CO2 emissions (% of total fuel combustion) of Denmark in 1987 to that in 1989?
Provide a short and direct response. 1.06. What is the ratio of the CO2 emissions (% of total fuel combustion) of High income in 1987 to that in 1990?
Provide a succinct answer. 0.9. What is the ratio of the CO2 emissions (% of total fuel combustion) of Latin America(all income levels) in 1987 to that in 1990?
Ensure brevity in your answer.  0.98. What is the ratio of the CO2 emissions (% of total fuel combustion) in Denmark in 1987 to that in 1990?
Provide a short and direct response. 1. What is the ratio of the CO2 emissions (% of total fuel combustion) in High income in 1988 to that in 1989?
Keep it short and to the point. 0.97. What is the ratio of the CO2 emissions (% of total fuel combustion) in Denmark in 1988 to that in 1989?
Make the answer very short. 1.06. What is the ratio of the CO2 emissions (% of total fuel combustion) of High income in 1988 to that in 1990?
Provide a short and direct response. 0.9. What is the ratio of the CO2 emissions (% of total fuel combustion) of Latin America(all income levels) in 1988 to that in 1990?
Your response must be concise. 1.02. What is the ratio of the CO2 emissions (% of total fuel combustion) in Denmark in 1988 to that in 1990?
Provide a succinct answer. 1. What is the ratio of the CO2 emissions (% of total fuel combustion) of High income in 1989 to that in 1990?
Give a very brief answer. 0.93. What is the ratio of the CO2 emissions (% of total fuel combustion) in Latin America(all income levels) in 1989 to that in 1990?
Offer a very short reply. 1.02. What is the ratio of the CO2 emissions (% of total fuel combustion) of Denmark in 1989 to that in 1990?
Provide a short and direct response. 0.94. What is the difference between the highest and the second highest CO2 emissions (% of total fuel combustion) of High income?
Give a very brief answer. 3.16. What is the difference between the highest and the second highest CO2 emissions (% of total fuel combustion) in Latin America(all income levels)?
Keep it short and to the point. 0.04. What is the difference between the highest and the second highest CO2 emissions (% of total fuel combustion) of Denmark?
Give a very brief answer. 0.12. What is the difference between the highest and the lowest CO2 emissions (% of total fuel combustion) of High income?
Keep it short and to the point. 4.79. What is the difference between the highest and the lowest CO2 emissions (% of total fuel combustion) of Latin America(all income levels)?
Provide a short and direct response. 2.49. What is the difference between the highest and the lowest CO2 emissions (% of total fuel combustion) in Denmark?
Keep it short and to the point. 3.23. 